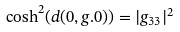<formula> <loc_0><loc_0><loc_500><loc_500>\cosh ^ { 2 } ( d ( 0 , g . 0 ) ) = | g _ { 3 3 } | ^ { 2 }</formula> 